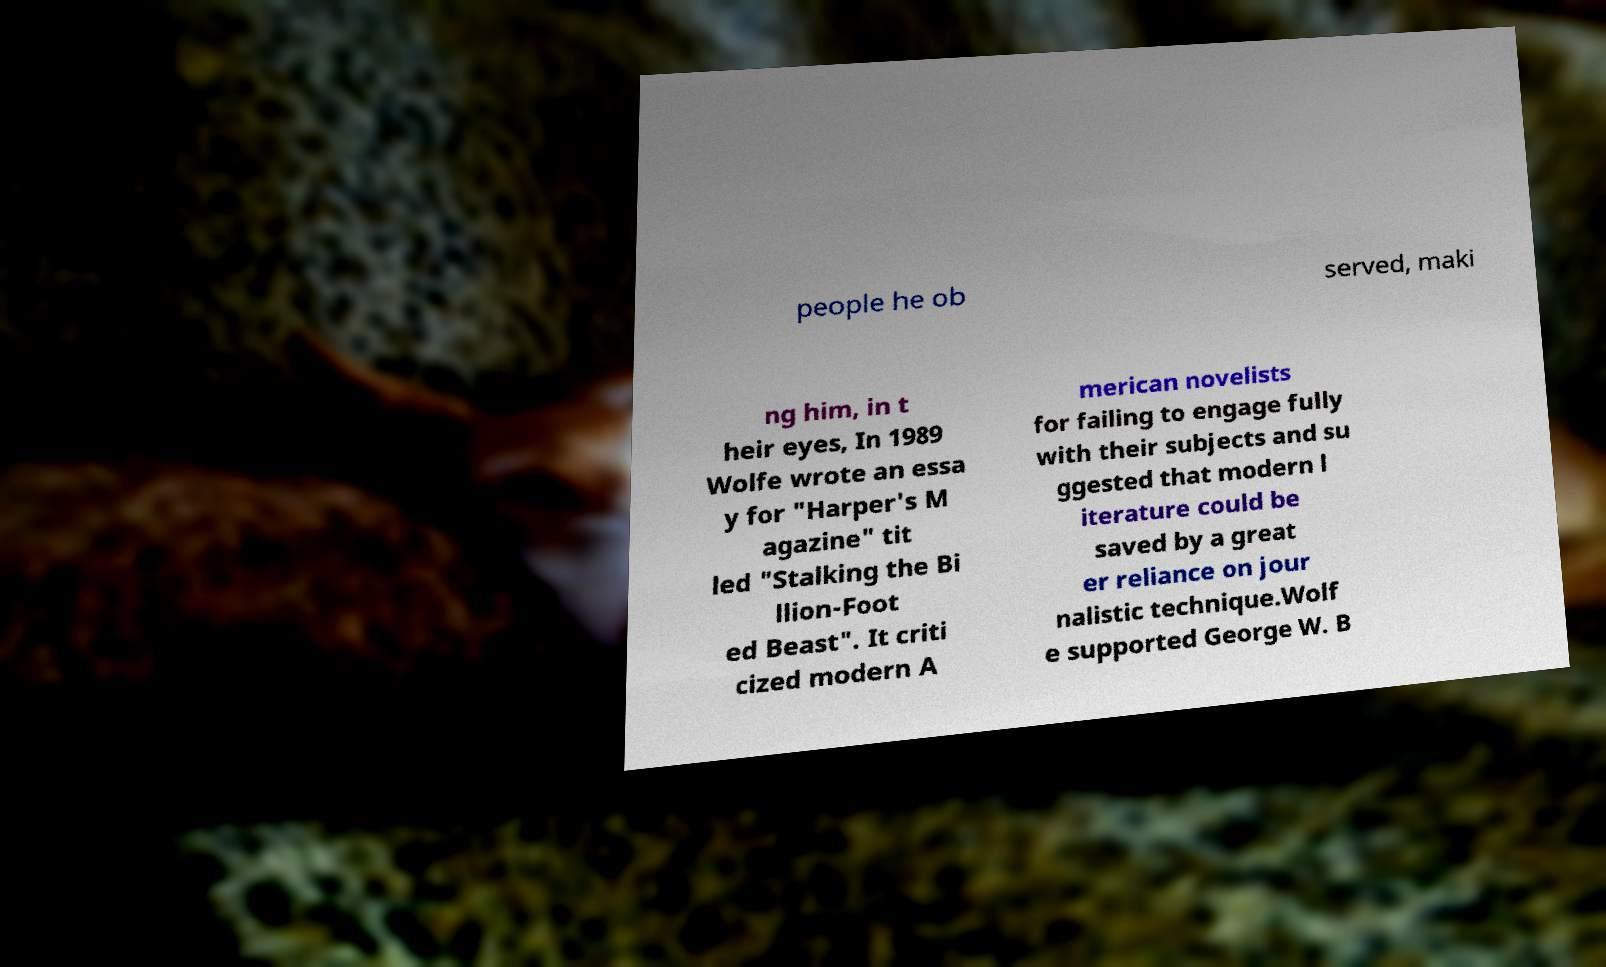Could you extract and type out the text from this image? people he ob served, maki ng him, in t heir eyes, In 1989 Wolfe wrote an essa y for "Harper's M agazine" tit led "Stalking the Bi llion-Foot ed Beast". It criti cized modern A merican novelists for failing to engage fully with their subjects and su ggested that modern l iterature could be saved by a great er reliance on jour nalistic technique.Wolf e supported George W. B 